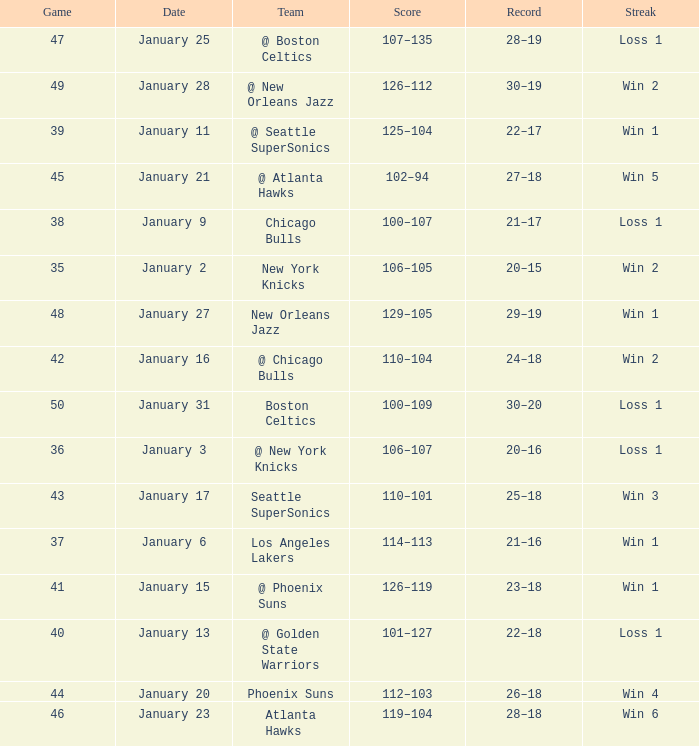What is the Team in Game 41? @ Phoenix Suns. 